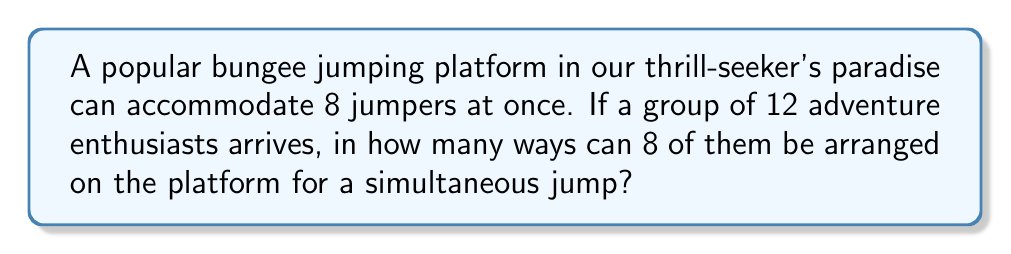Could you help me with this problem? Let's approach this step-by-step:

1) First, we need to choose 8 people out of 12 to be on the platform. This is a combination problem, denoted as $\binom{12}{8}$ or $C(12,8)$.

2) The number of ways to choose 8 people out of 12 is:

   $$\binom{12}{8} = \frac{12!}{8!(12-8)!} = \frac{12!}{8!4!}$$

3) Now, for each of these combinations, we need to arrange the 8 chosen people on the platform. This is a permutation of 8 people, which is simply 8!.

4) By the multiplication principle, the total number of ways to arrange 8 people out of 12 on the platform is:

   $$\binom{12}{8} \cdot 8!$$

5) Let's calculate this:
   
   $$\frac{12!}{8!4!} \cdot 8! = \frac{12!}{4!}$$

6) Simplifying:
   
   $$\frac{12 \cdot 11 \cdot 10 \cdot 9 \cdot 8!}{4 \cdot 3 \cdot 2 \cdot 1} = 11,880$$

Therefore, there are 11,880 ways to arrange 8 out of 12 thrill-seekers on the bungee jumping platform.
Answer: 11,880 